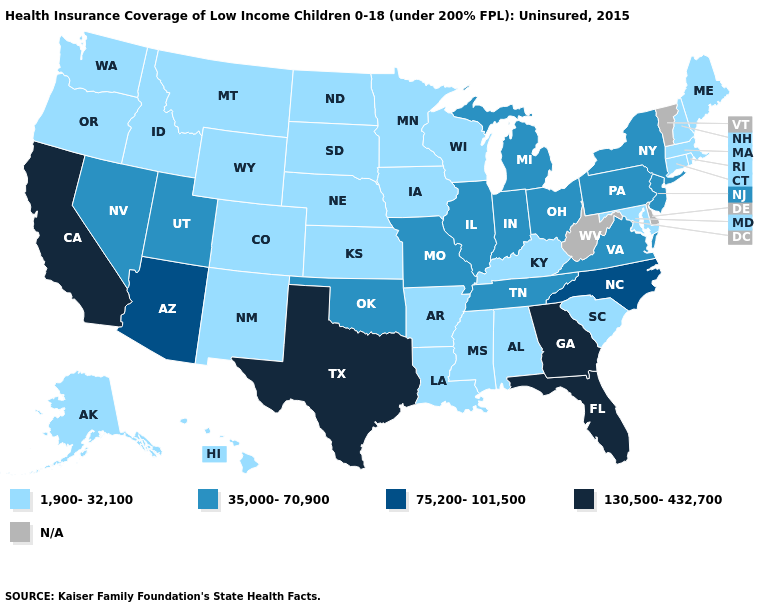Does the map have missing data?
Quick response, please. Yes. Name the states that have a value in the range 1,900-32,100?
Give a very brief answer. Alabama, Alaska, Arkansas, Colorado, Connecticut, Hawaii, Idaho, Iowa, Kansas, Kentucky, Louisiana, Maine, Maryland, Massachusetts, Minnesota, Mississippi, Montana, Nebraska, New Hampshire, New Mexico, North Dakota, Oregon, Rhode Island, South Carolina, South Dakota, Washington, Wisconsin, Wyoming. What is the highest value in states that border Texas?
Be succinct. 35,000-70,900. Which states hav the highest value in the MidWest?
Answer briefly. Illinois, Indiana, Michigan, Missouri, Ohio. Name the states that have a value in the range 75,200-101,500?
Short answer required. Arizona, North Carolina. Is the legend a continuous bar?
Short answer required. No. What is the value of North Carolina?
Write a very short answer. 75,200-101,500. Does the map have missing data?
Give a very brief answer. Yes. Name the states that have a value in the range N/A?
Be succinct. Delaware, Vermont, West Virginia. Does Arizona have the lowest value in the USA?
Write a very short answer. No. How many symbols are there in the legend?
Write a very short answer. 5. Does Arkansas have the lowest value in the USA?
Be succinct. Yes. Name the states that have a value in the range 130,500-432,700?
Be succinct. California, Florida, Georgia, Texas. What is the value of Montana?
Quick response, please. 1,900-32,100. 